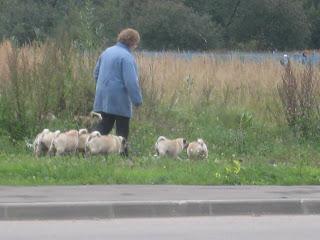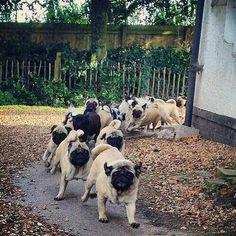The first image is the image on the left, the second image is the image on the right. For the images shown, is this caption "A person is standing in one of the images." true? Answer yes or no. Yes. 